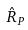<formula> <loc_0><loc_0><loc_500><loc_500>\hat { R } _ { P }</formula> 